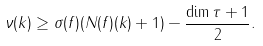<formula> <loc_0><loc_0><loc_500><loc_500>\nu ( k ) \geq \sigma ( f ) ( N ( f ) ( k ) + 1 ) - \frac { \dim \tau + 1 } { 2 } .</formula> 